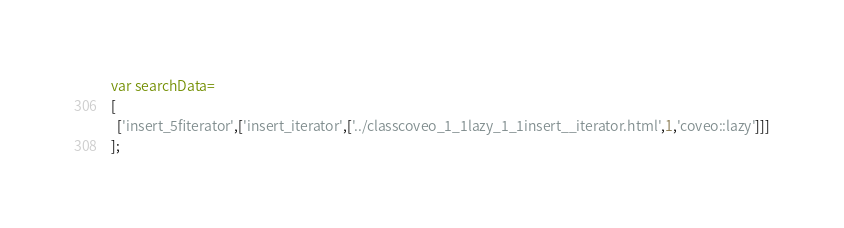Convert code to text. <code><loc_0><loc_0><loc_500><loc_500><_JavaScript_>var searchData=
[
  ['insert_5fiterator',['insert_iterator',['../classcoveo_1_1lazy_1_1insert__iterator.html',1,'coveo::lazy']]]
];
</code> 